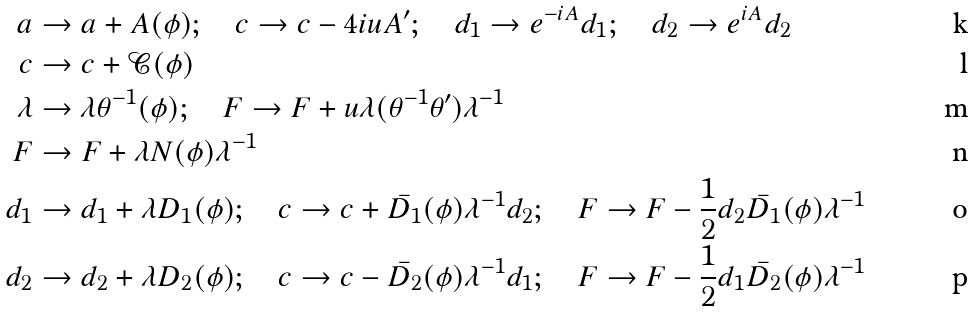Convert formula to latex. <formula><loc_0><loc_0><loc_500><loc_500>a & \rightarrow a + A ( \phi ) ; \quad c \rightarrow c - 4 i u A ^ { \prime } ; \quad d _ { 1 } \rightarrow e ^ { - i A } d _ { 1 } ; \quad d _ { 2 } \rightarrow e ^ { i A } d _ { 2 } \\ c & \rightarrow c + \mathcal { C } ( \phi ) \\ \lambda & \rightarrow \lambda \theta ^ { - 1 } ( \phi ) ; \quad F \rightarrow F + u \lambda ( \theta ^ { - 1 } \theta ^ { \prime } ) \lambda ^ { - 1 } \\ F & \rightarrow F + \lambda N ( \phi ) \lambda ^ { - 1 } \\ d _ { 1 } & \rightarrow d _ { 1 } + \lambda D _ { 1 } ( \phi ) ; \quad c \rightarrow c + \bar { D _ { 1 } } ( \phi ) \lambda ^ { - 1 } d _ { 2 } ; \quad F \rightarrow F - \frac { 1 } { 2 } d _ { 2 } \bar { D _ { 1 } } ( \phi ) \lambda ^ { - 1 } \\ d _ { 2 } & \rightarrow d _ { 2 } + \lambda D _ { 2 } ( \phi ) ; \quad c \rightarrow c - \bar { D _ { 2 } } ( \phi ) \lambda ^ { - 1 } d _ { 1 } ; \quad F \rightarrow F - \frac { 1 } { 2 } d _ { 1 } \bar { D _ { 2 } } ( \phi ) \lambda ^ { - 1 }</formula> 